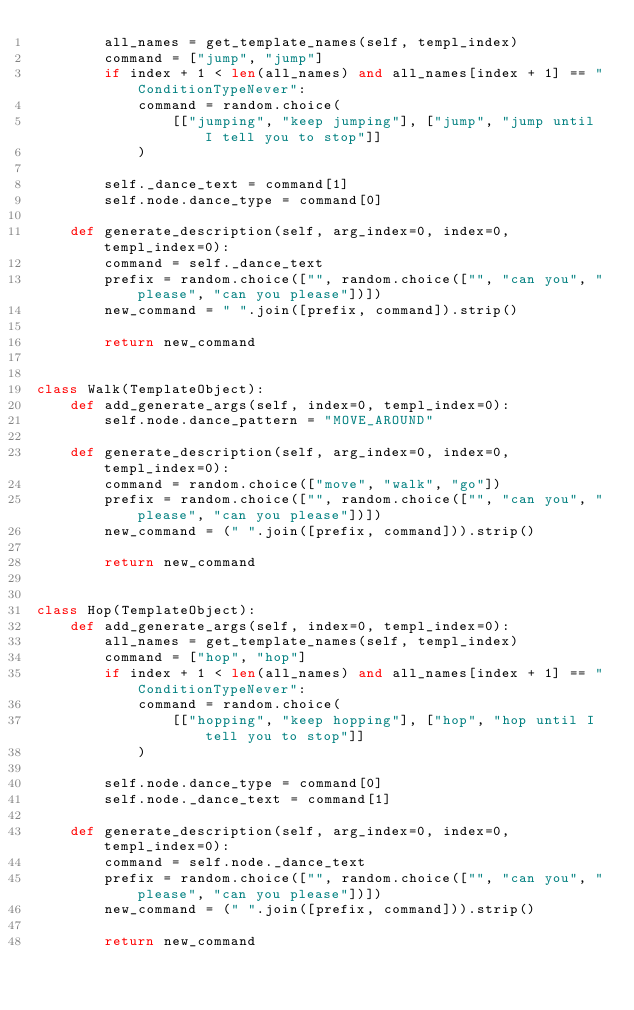Convert code to text. <code><loc_0><loc_0><loc_500><loc_500><_Python_>        all_names = get_template_names(self, templ_index)
        command = ["jump", "jump"]
        if index + 1 < len(all_names) and all_names[index + 1] == "ConditionTypeNever":
            command = random.choice(
                [["jumping", "keep jumping"], ["jump", "jump until I tell you to stop"]]
            )

        self._dance_text = command[1]
        self.node.dance_type = command[0]

    def generate_description(self, arg_index=0, index=0, templ_index=0):
        command = self._dance_text
        prefix = random.choice(["", random.choice(["", "can you", "please", "can you please"])])
        new_command = " ".join([prefix, command]).strip()

        return new_command


class Walk(TemplateObject):
    def add_generate_args(self, index=0, templ_index=0):
        self.node.dance_pattern = "MOVE_AROUND"

    def generate_description(self, arg_index=0, index=0, templ_index=0):
        command = random.choice(["move", "walk", "go"])
        prefix = random.choice(["", random.choice(["", "can you", "please", "can you please"])])
        new_command = (" ".join([prefix, command])).strip()

        return new_command


class Hop(TemplateObject):
    def add_generate_args(self, index=0, templ_index=0):
        all_names = get_template_names(self, templ_index)
        command = ["hop", "hop"]
        if index + 1 < len(all_names) and all_names[index + 1] == "ConditionTypeNever":
            command = random.choice(
                [["hopping", "keep hopping"], ["hop", "hop until I tell you to stop"]]
            )

        self.node.dance_type = command[0]
        self.node._dance_text = command[1]

    def generate_description(self, arg_index=0, index=0, templ_index=0):
        command = self.node._dance_text
        prefix = random.choice(["", random.choice(["", "can you", "please", "can you please"])])
        new_command = (" ".join([prefix, command])).strip()

        return new_command
</code> 